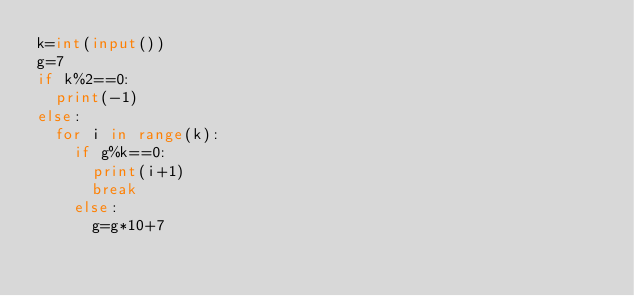<code> <loc_0><loc_0><loc_500><loc_500><_Python_>k=int(input())
g=7
if k%2==0:
  print(-1)
else:
  for i in range(k):
    if g%k==0:
      print(i+1)
      break
    else:
      g=g*10+7</code> 